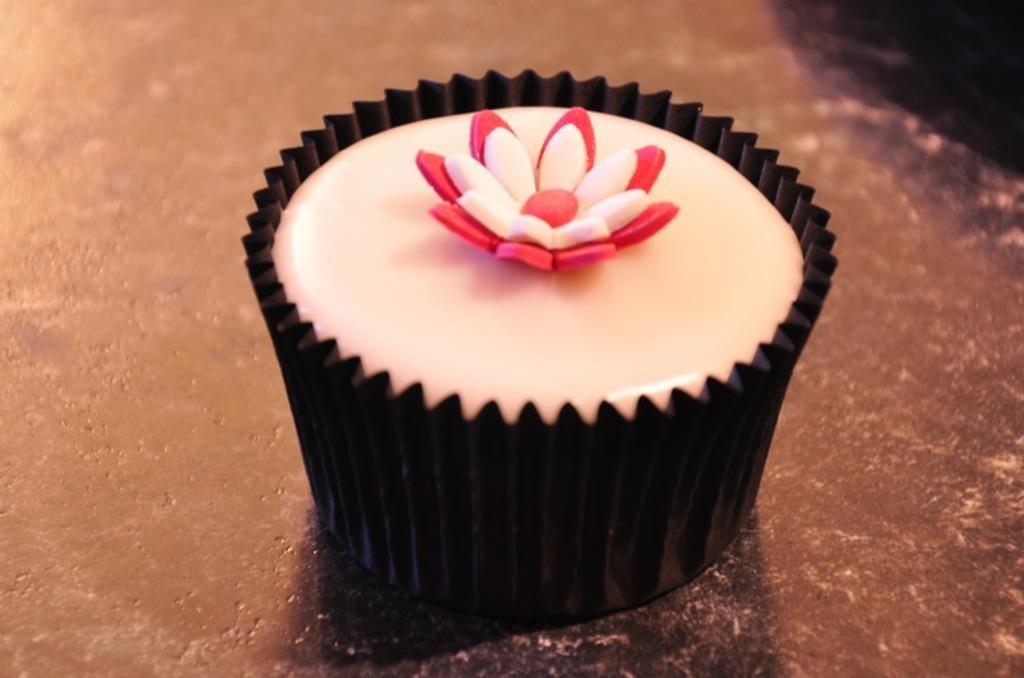Please provide a concise description of this image. In this image, we can see a cupcake. 